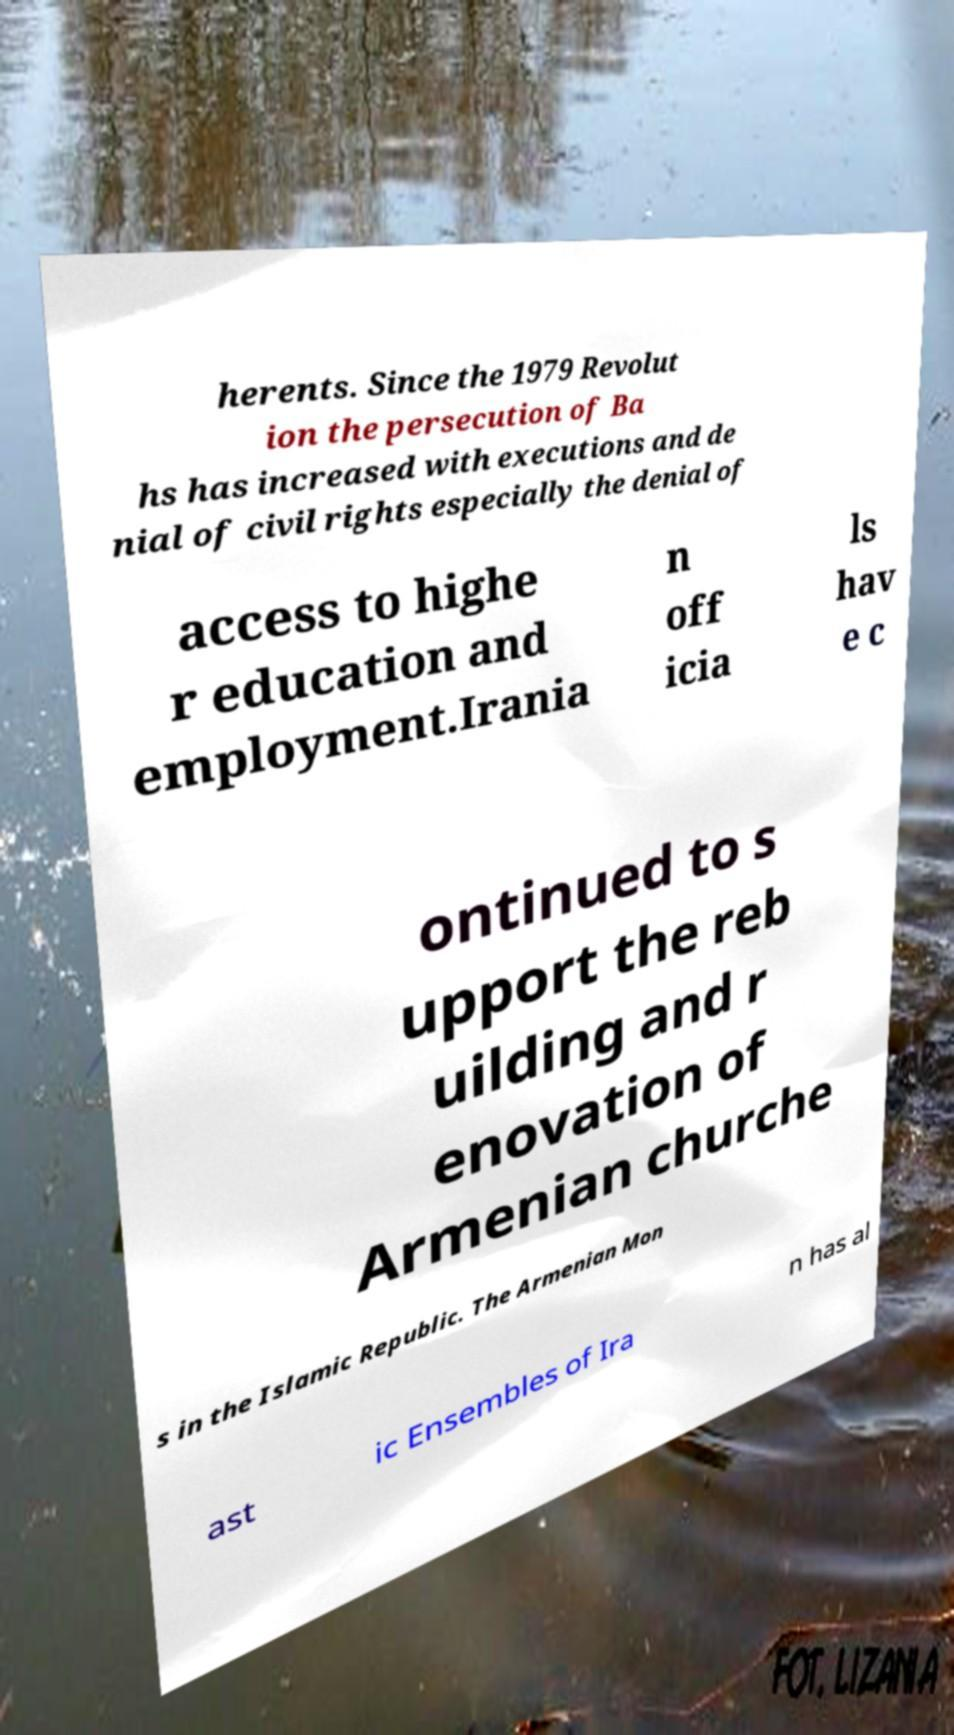What messages or text are displayed in this image? I need them in a readable, typed format. herents. Since the 1979 Revolut ion the persecution of Ba hs has increased with executions and de nial of civil rights especially the denial of access to highe r education and employment.Irania n off icia ls hav e c ontinued to s upport the reb uilding and r enovation of Armenian churche s in the Islamic Republic. The Armenian Mon ast ic Ensembles of Ira n has al 